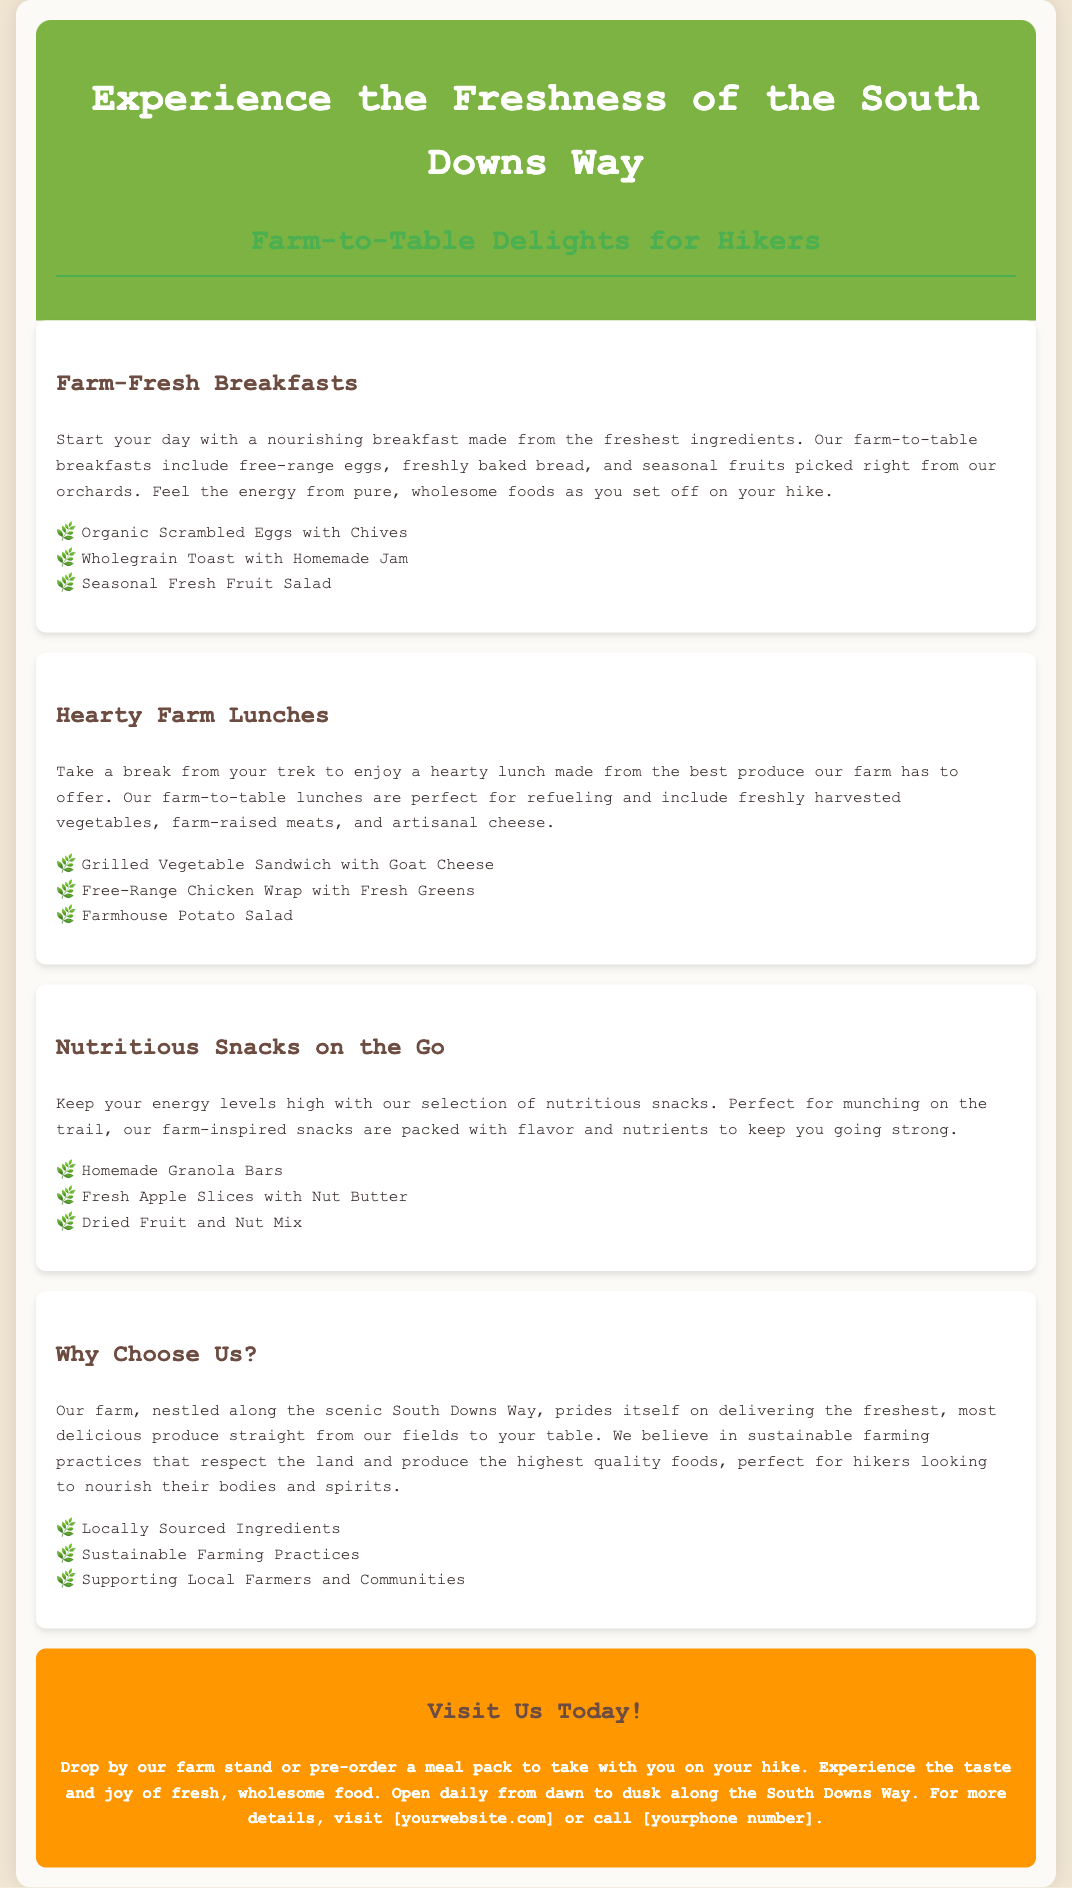What meals are offered for breakfast? The document lists the breakfast options such as Organic Scrambled Eggs with Chives, Wholegrain Toast with Homemade Jam, and Seasonal Fresh Fruit Salad.
Answer: Organic Scrambled Eggs with Chives, Wholegrain Toast with Homemade Jam, Seasonal Fresh Fruit Salad What is included in the farm lunches? The lunch options include Grilled Vegetable Sandwich with Goat Cheese, Free-Range Chicken Wrap with Fresh Greens, and Farmhouse Potato Salad.
Answer: Grilled Vegetable Sandwich with Goat Cheese, Free-Range Chicken Wrap with Fresh Greens, Farmhouse Potato Salad What organic produce is mentioned for breakfast? The document specifies free-range eggs, freshly baked bread, and seasonal fruits which are the organic produce for breakfast.
Answer: Free-range eggs, freshly baked bread, seasonal fruits What type of snacks are available for hikers? The document describes the snack options which include Homemade Granola Bars, Fresh Apple Slices with Nut Butter, and Dried Fruit and Nut Mix.
Answer: Homemade Granola Bars, Fresh Apple Slices with Nut Butter, Dried Fruit and Nut Mix How does the farm ensure quality? The document states that the farm prides itself on delivering fresh produce, utilizing sustainable farming practices, and supporting local farmers and communities.
Answer: Sustainable farming practices What is the main selling point of the farm? The advertisement highlights the freshness of the produce and the commitment to sustainable farming practices as the main selling points.
Answer: Freshness of the produce What time is the farm open? The document mentions that the farm is open daily from dawn to dusk.
Answer: Dawn to dusk Where can customers pre-order meals? The advertisement encourages visitors to pre-order a meal pack to take with them during their hike.
Answer: Meal pack 